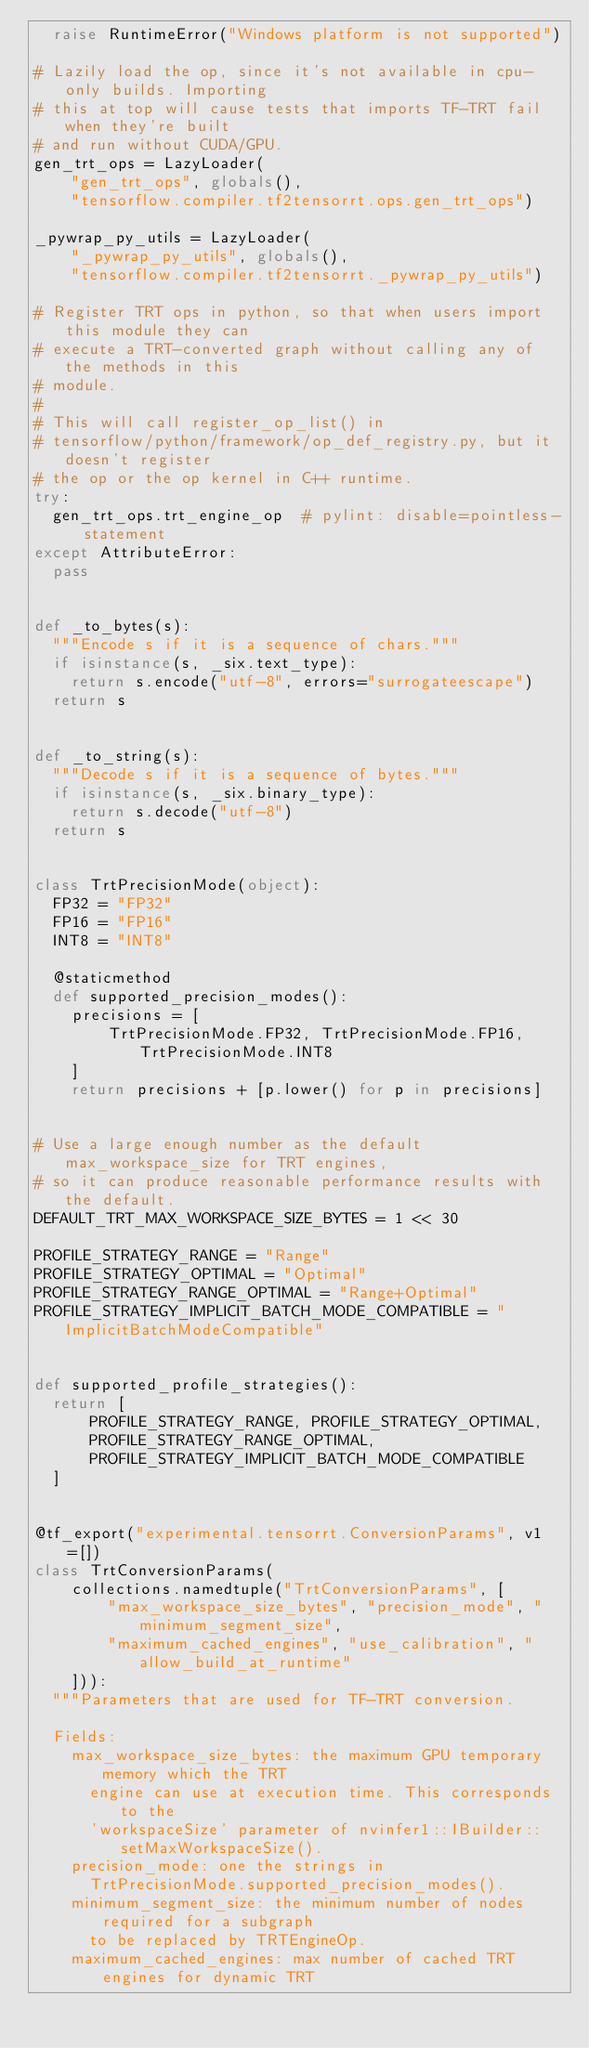Convert code to text. <code><loc_0><loc_0><loc_500><loc_500><_Python_>  raise RuntimeError("Windows platform is not supported")

# Lazily load the op, since it's not available in cpu-only builds. Importing
# this at top will cause tests that imports TF-TRT fail when they're built
# and run without CUDA/GPU.
gen_trt_ops = LazyLoader(
    "gen_trt_ops", globals(),
    "tensorflow.compiler.tf2tensorrt.ops.gen_trt_ops")

_pywrap_py_utils = LazyLoader(
    "_pywrap_py_utils", globals(),
    "tensorflow.compiler.tf2tensorrt._pywrap_py_utils")

# Register TRT ops in python, so that when users import this module they can
# execute a TRT-converted graph without calling any of the methods in this
# module.
#
# This will call register_op_list() in
# tensorflow/python/framework/op_def_registry.py, but it doesn't register
# the op or the op kernel in C++ runtime.
try:
  gen_trt_ops.trt_engine_op  # pylint: disable=pointless-statement
except AttributeError:
  pass


def _to_bytes(s):
  """Encode s if it is a sequence of chars."""
  if isinstance(s, _six.text_type):
    return s.encode("utf-8", errors="surrogateescape")
  return s


def _to_string(s):
  """Decode s if it is a sequence of bytes."""
  if isinstance(s, _six.binary_type):
    return s.decode("utf-8")
  return s


class TrtPrecisionMode(object):
  FP32 = "FP32"
  FP16 = "FP16"
  INT8 = "INT8"

  @staticmethod
  def supported_precision_modes():
    precisions = [
        TrtPrecisionMode.FP32, TrtPrecisionMode.FP16, TrtPrecisionMode.INT8
    ]
    return precisions + [p.lower() for p in precisions]


# Use a large enough number as the default max_workspace_size for TRT engines,
# so it can produce reasonable performance results with the default.
DEFAULT_TRT_MAX_WORKSPACE_SIZE_BYTES = 1 << 30

PROFILE_STRATEGY_RANGE = "Range"
PROFILE_STRATEGY_OPTIMAL = "Optimal"
PROFILE_STRATEGY_RANGE_OPTIMAL = "Range+Optimal"
PROFILE_STRATEGY_IMPLICIT_BATCH_MODE_COMPATIBLE = "ImplicitBatchModeCompatible"


def supported_profile_strategies():
  return [
      PROFILE_STRATEGY_RANGE, PROFILE_STRATEGY_OPTIMAL,
      PROFILE_STRATEGY_RANGE_OPTIMAL,
      PROFILE_STRATEGY_IMPLICIT_BATCH_MODE_COMPATIBLE
  ]


@tf_export("experimental.tensorrt.ConversionParams", v1=[])
class TrtConversionParams(
    collections.namedtuple("TrtConversionParams", [
        "max_workspace_size_bytes", "precision_mode", "minimum_segment_size",
        "maximum_cached_engines", "use_calibration", "allow_build_at_runtime"
    ])):
  """Parameters that are used for TF-TRT conversion.

  Fields:
    max_workspace_size_bytes: the maximum GPU temporary memory which the TRT
      engine can use at execution time. This corresponds to the
      'workspaceSize' parameter of nvinfer1::IBuilder::setMaxWorkspaceSize().
    precision_mode: one the strings in
      TrtPrecisionMode.supported_precision_modes().
    minimum_segment_size: the minimum number of nodes required for a subgraph
      to be replaced by TRTEngineOp.
    maximum_cached_engines: max number of cached TRT engines for dynamic TRT</code> 